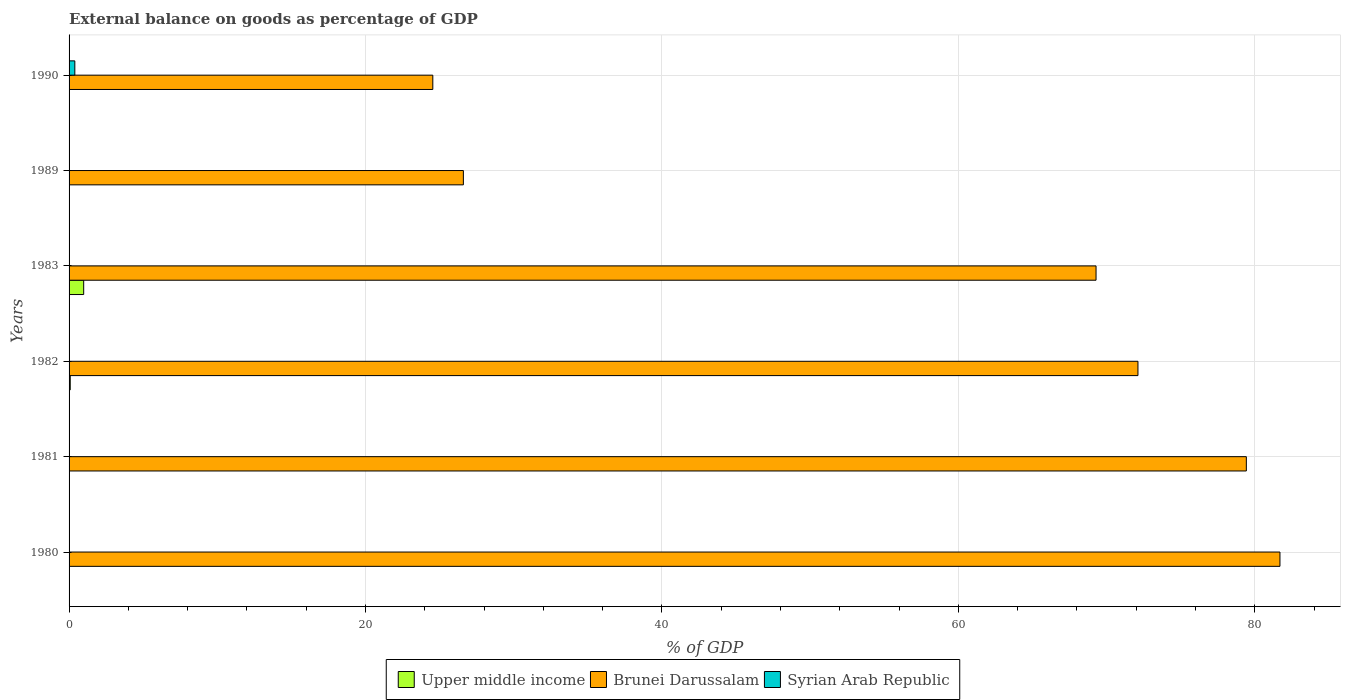How many different coloured bars are there?
Offer a very short reply. 3. Are the number of bars per tick equal to the number of legend labels?
Keep it short and to the point. No. In how many cases, is the number of bars for a given year not equal to the number of legend labels?
Your answer should be very brief. 6. What is the external balance on goods as percentage of GDP in Brunei Darussalam in 1981?
Keep it short and to the point. 79.43. Across all years, what is the maximum external balance on goods as percentage of GDP in Brunei Darussalam?
Ensure brevity in your answer.  81.7. What is the total external balance on goods as percentage of GDP in Upper middle income in the graph?
Keep it short and to the point. 1.07. What is the difference between the external balance on goods as percentage of GDP in Brunei Darussalam in 1980 and that in 1981?
Offer a very short reply. 2.27. What is the difference between the external balance on goods as percentage of GDP in Syrian Arab Republic in 1981 and the external balance on goods as percentage of GDP in Brunei Darussalam in 1989?
Give a very brief answer. -26.6. What is the average external balance on goods as percentage of GDP in Syrian Arab Republic per year?
Your answer should be very brief. 0.06. In the year 1983, what is the difference between the external balance on goods as percentage of GDP in Upper middle income and external balance on goods as percentage of GDP in Brunei Darussalam?
Provide a short and direct response. -68.3. What is the ratio of the external balance on goods as percentage of GDP in Brunei Darussalam in 1981 to that in 1982?
Keep it short and to the point. 1.1. What is the difference between the highest and the second highest external balance on goods as percentage of GDP in Brunei Darussalam?
Make the answer very short. 2.27. What is the difference between the highest and the lowest external balance on goods as percentage of GDP in Syrian Arab Republic?
Offer a terse response. 0.39. In how many years, is the external balance on goods as percentage of GDP in Brunei Darussalam greater than the average external balance on goods as percentage of GDP in Brunei Darussalam taken over all years?
Your answer should be compact. 4. Are all the bars in the graph horizontal?
Offer a terse response. Yes. How many years are there in the graph?
Provide a short and direct response. 6. What is the difference between two consecutive major ticks on the X-axis?
Provide a succinct answer. 20. Are the values on the major ticks of X-axis written in scientific E-notation?
Keep it short and to the point. No. Does the graph contain any zero values?
Provide a short and direct response. Yes. Where does the legend appear in the graph?
Give a very brief answer. Bottom center. How many legend labels are there?
Keep it short and to the point. 3. How are the legend labels stacked?
Your response must be concise. Horizontal. What is the title of the graph?
Your answer should be compact. External balance on goods as percentage of GDP. Does "Low income" appear as one of the legend labels in the graph?
Offer a very short reply. No. What is the label or title of the X-axis?
Make the answer very short. % of GDP. What is the % of GDP of Upper middle income in 1980?
Give a very brief answer. 0. What is the % of GDP in Brunei Darussalam in 1980?
Your response must be concise. 81.7. What is the % of GDP in Syrian Arab Republic in 1980?
Provide a short and direct response. 0. What is the % of GDP in Upper middle income in 1981?
Keep it short and to the point. 0. What is the % of GDP of Brunei Darussalam in 1981?
Keep it short and to the point. 79.43. What is the % of GDP in Upper middle income in 1982?
Your answer should be very brief. 0.08. What is the % of GDP in Brunei Darussalam in 1982?
Your response must be concise. 72.12. What is the % of GDP in Syrian Arab Republic in 1982?
Provide a short and direct response. 0. What is the % of GDP in Upper middle income in 1983?
Provide a short and direct response. 0.99. What is the % of GDP of Brunei Darussalam in 1983?
Provide a succinct answer. 69.29. What is the % of GDP in Brunei Darussalam in 1989?
Your response must be concise. 26.6. What is the % of GDP of Syrian Arab Republic in 1989?
Ensure brevity in your answer.  0. What is the % of GDP in Brunei Darussalam in 1990?
Your answer should be compact. 24.54. What is the % of GDP in Syrian Arab Republic in 1990?
Your answer should be compact. 0.39. Across all years, what is the maximum % of GDP in Upper middle income?
Your response must be concise. 0.99. Across all years, what is the maximum % of GDP in Brunei Darussalam?
Offer a very short reply. 81.7. Across all years, what is the maximum % of GDP in Syrian Arab Republic?
Your answer should be compact. 0.39. Across all years, what is the minimum % of GDP in Brunei Darussalam?
Keep it short and to the point. 24.54. Across all years, what is the minimum % of GDP of Syrian Arab Republic?
Make the answer very short. 0. What is the total % of GDP in Upper middle income in the graph?
Your response must be concise. 1.07. What is the total % of GDP in Brunei Darussalam in the graph?
Your answer should be compact. 353.68. What is the total % of GDP of Syrian Arab Republic in the graph?
Your answer should be compact. 0.39. What is the difference between the % of GDP of Brunei Darussalam in 1980 and that in 1981?
Keep it short and to the point. 2.27. What is the difference between the % of GDP of Brunei Darussalam in 1980 and that in 1982?
Offer a very short reply. 9.58. What is the difference between the % of GDP of Brunei Darussalam in 1980 and that in 1983?
Keep it short and to the point. 12.41. What is the difference between the % of GDP in Brunei Darussalam in 1980 and that in 1989?
Ensure brevity in your answer.  55.09. What is the difference between the % of GDP in Brunei Darussalam in 1980 and that in 1990?
Keep it short and to the point. 57.16. What is the difference between the % of GDP of Brunei Darussalam in 1981 and that in 1982?
Make the answer very short. 7.31. What is the difference between the % of GDP in Brunei Darussalam in 1981 and that in 1983?
Your response must be concise. 10.14. What is the difference between the % of GDP of Brunei Darussalam in 1981 and that in 1989?
Give a very brief answer. 52.83. What is the difference between the % of GDP in Brunei Darussalam in 1981 and that in 1990?
Your response must be concise. 54.89. What is the difference between the % of GDP of Upper middle income in 1982 and that in 1983?
Give a very brief answer. -0.91. What is the difference between the % of GDP of Brunei Darussalam in 1982 and that in 1983?
Your answer should be very brief. 2.83. What is the difference between the % of GDP of Brunei Darussalam in 1982 and that in 1989?
Your answer should be compact. 45.51. What is the difference between the % of GDP in Brunei Darussalam in 1982 and that in 1990?
Keep it short and to the point. 47.58. What is the difference between the % of GDP in Brunei Darussalam in 1983 and that in 1989?
Provide a short and direct response. 42.69. What is the difference between the % of GDP in Brunei Darussalam in 1983 and that in 1990?
Your answer should be compact. 44.75. What is the difference between the % of GDP of Brunei Darussalam in 1989 and that in 1990?
Offer a terse response. 2.06. What is the difference between the % of GDP in Brunei Darussalam in 1980 and the % of GDP in Syrian Arab Republic in 1990?
Provide a short and direct response. 81.31. What is the difference between the % of GDP in Brunei Darussalam in 1981 and the % of GDP in Syrian Arab Republic in 1990?
Your answer should be very brief. 79.04. What is the difference between the % of GDP in Upper middle income in 1982 and the % of GDP in Brunei Darussalam in 1983?
Ensure brevity in your answer.  -69.21. What is the difference between the % of GDP of Upper middle income in 1982 and the % of GDP of Brunei Darussalam in 1989?
Provide a succinct answer. -26.52. What is the difference between the % of GDP of Upper middle income in 1982 and the % of GDP of Brunei Darussalam in 1990?
Offer a terse response. -24.46. What is the difference between the % of GDP of Upper middle income in 1982 and the % of GDP of Syrian Arab Republic in 1990?
Give a very brief answer. -0.31. What is the difference between the % of GDP of Brunei Darussalam in 1982 and the % of GDP of Syrian Arab Republic in 1990?
Your answer should be very brief. 71.73. What is the difference between the % of GDP of Upper middle income in 1983 and the % of GDP of Brunei Darussalam in 1989?
Give a very brief answer. -25.62. What is the difference between the % of GDP of Upper middle income in 1983 and the % of GDP of Brunei Darussalam in 1990?
Offer a terse response. -23.56. What is the difference between the % of GDP in Upper middle income in 1983 and the % of GDP in Syrian Arab Republic in 1990?
Offer a very short reply. 0.6. What is the difference between the % of GDP in Brunei Darussalam in 1983 and the % of GDP in Syrian Arab Republic in 1990?
Ensure brevity in your answer.  68.9. What is the difference between the % of GDP of Brunei Darussalam in 1989 and the % of GDP of Syrian Arab Republic in 1990?
Your answer should be very brief. 26.22. What is the average % of GDP of Upper middle income per year?
Provide a short and direct response. 0.18. What is the average % of GDP in Brunei Darussalam per year?
Make the answer very short. 58.95. What is the average % of GDP of Syrian Arab Republic per year?
Give a very brief answer. 0.06. In the year 1982, what is the difference between the % of GDP in Upper middle income and % of GDP in Brunei Darussalam?
Your answer should be compact. -72.04. In the year 1983, what is the difference between the % of GDP in Upper middle income and % of GDP in Brunei Darussalam?
Your answer should be very brief. -68.3. In the year 1990, what is the difference between the % of GDP of Brunei Darussalam and % of GDP of Syrian Arab Republic?
Your response must be concise. 24.15. What is the ratio of the % of GDP in Brunei Darussalam in 1980 to that in 1981?
Ensure brevity in your answer.  1.03. What is the ratio of the % of GDP of Brunei Darussalam in 1980 to that in 1982?
Your response must be concise. 1.13. What is the ratio of the % of GDP of Brunei Darussalam in 1980 to that in 1983?
Your response must be concise. 1.18. What is the ratio of the % of GDP of Brunei Darussalam in 1980 to that in 1989?
Make the answer very short. 3.07. What is the ratio of the % of GDP of Brunei Darussalam in 1980 to that in 1990?
Provide a short and direct response. 3.33. What is the ratio of the % of GDP of Brunei Darussalam in 1981 to that in 1982?
Give a very brief answer. 1.1. What is the ratio of the % of GDP of Brunei Darussalam in 1981 to that in 1983?
Provide a succinct answer. 1.15. What is the ratio of the % of GDP in Brunei Darussalam in 1981 to that in 1989?
Ensure brevity in your answer.  2.99. What is the ratio of the % of GDP of Brunei Darussalam in 1981 to that in 1990?
Give a very brief answer. 3.24. What is the ratio of the % of GDP of Upper middle income in 1982 to that in 1983?
Offer a terse response. 0.08. What is the ratio of the % of GDP of Brunei Darussalam in 1982 to that in 1983?
Your response must be concise. 1.04. What is the ratio of the % of GDP of Brunei Darussalam in 1982 to that in 1989?
Your answer should be compact. 2.71. What is the ratio of the % of GDP in Brunei Darussalam in 1982 to that in 1990?
Keep it short and to the point. 2.94. What is the ratio of the % of GDP in Brunei Darussalam in 1983 to that in 1989?
Your answer should be compact. 2.6. What is the ratio of the % of GDP of Brunei Darussalam in 1983 to that in 1990?
Offer a terse response. 2.82. What is the ratio of the % of GDP in Brunei Darussalam in 1989 to that in 1990?
Ensure brevity in your answer.  1.08. What is the difference between the highest and the second highest % of GDP in Brunei Darussalam?
Ensure brevity in your answer.  2.27. What is the difference between the highest and the lowest % of GDP in Upper middle income?
Keep it short and to the point. 0.99. What is the difference between the highest and the lowest % of GDP in Brunei Darussalam?
Ensure brevity in your answer.  57.16. What is the difference between the highest and the lowest % of GDP in Syrian Arab Republic?
Your answer should be very brief. 0.39. 